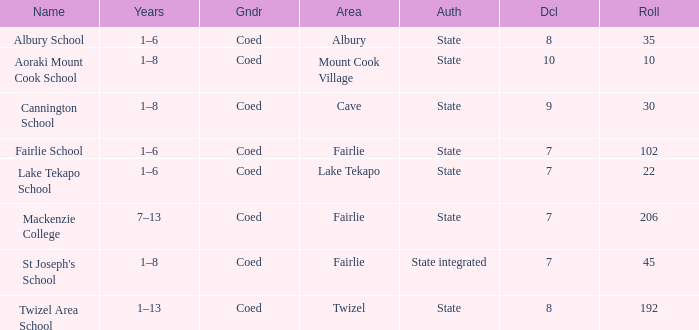What area is named Mackenzie college? Fairlie. 